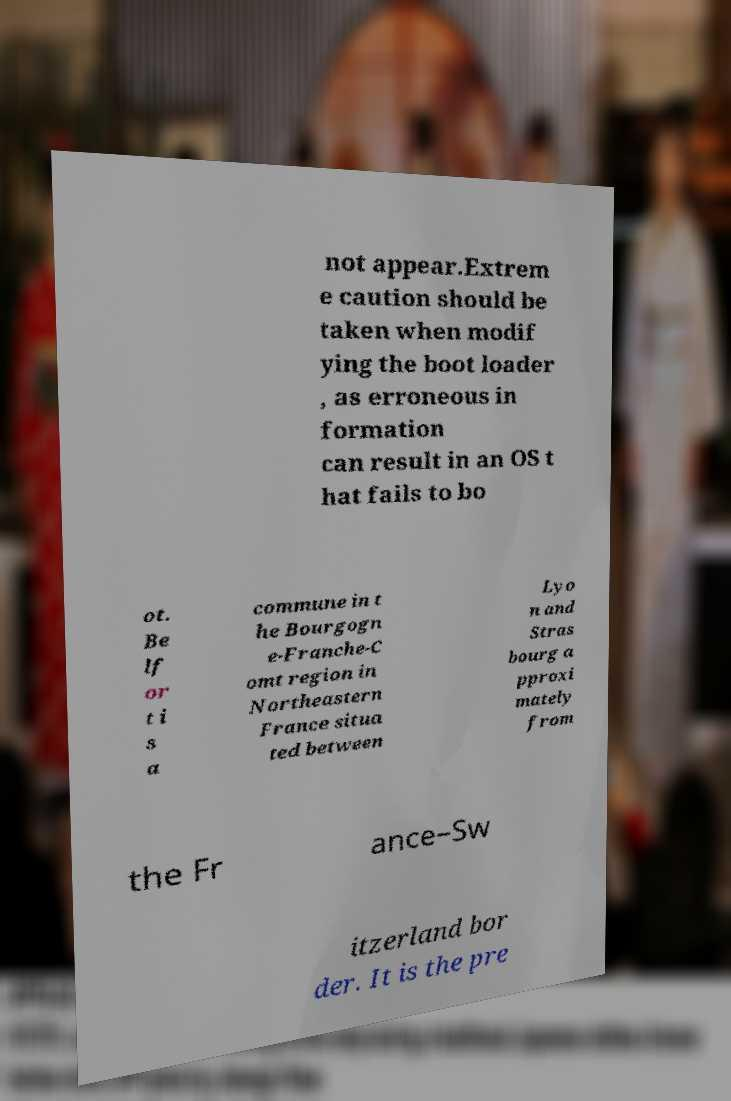Please read and relay the text visible in this image. What does it say? not appear.Extrem e caution should be taken when modif ying the boot loader , as erroneous in formation can result in an OS t hat fails to bo ot. Be lf or t i s a commune in t he Bourgogn e-Franche-C omt region in Northeastern France situa ted between Lyo n and Stras bourg a pproxi mately from the Fr ance–Sw itzerland bor der. It is the pre 